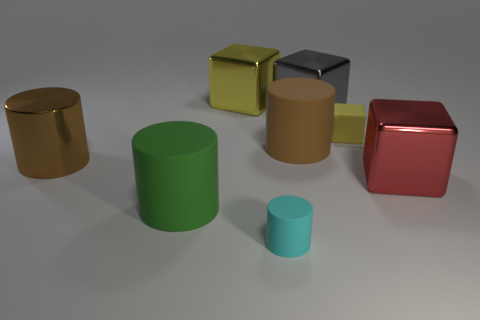Subtract all big shiny cubes. How many cubes are left? 1 Subtract 1 cubes. How many cubes are left? 3 Subtract all red cubes. How many cubes are left? 3 Subtract all green cubes. Subtract all green cylinders. How many cubes are left? 4 Add 2 cyan rubber objects. How many objects exist? 10 Add 4 cyan metal cylinders. How many cyan metal cylinders exist? 4 Subtract 1 yellow cubes. How many objects are left? 7 Subtract all small purple metal blocks. Subtract all big green cylinders. How many objects are left? 7 Add 2 large metal things. How many large metal things are left? 6 